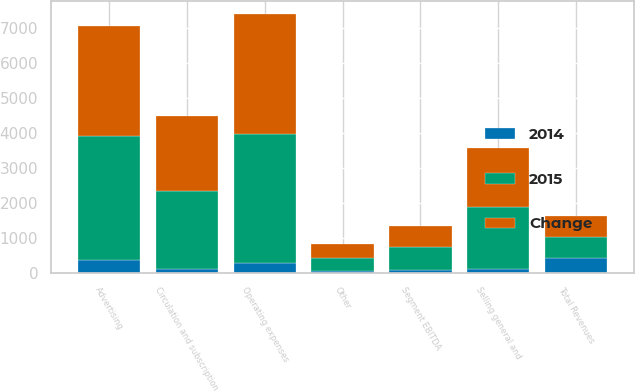Convert chart to OTSL. <chart><loc_0><loc_0><loc_500><loc_500><stacked_bar_chart><ecel><fcel>Advertising<fcel>Circulation and subscription<fcel>Other<fcel>Total Revenues<fcel>Operating expenses<fcel>Selling general and<fcel>Segment EBITDA<nl><fcel>Change<fcel>3163<fcel>2159<fcel>409<fcel>603<fcel>3442<fcel>1686<fcel>603<nl><fcel>2015<fcel>3529<fcel>2245<fcel>379<fcel>603<fcel>3706<fcel>1782<fcel>665<nl><fcel>2014<fcel>366<fcel>86<fcel>30<fcel>422<fcel>264<fcel>96<fcel>62<nl></chart> 